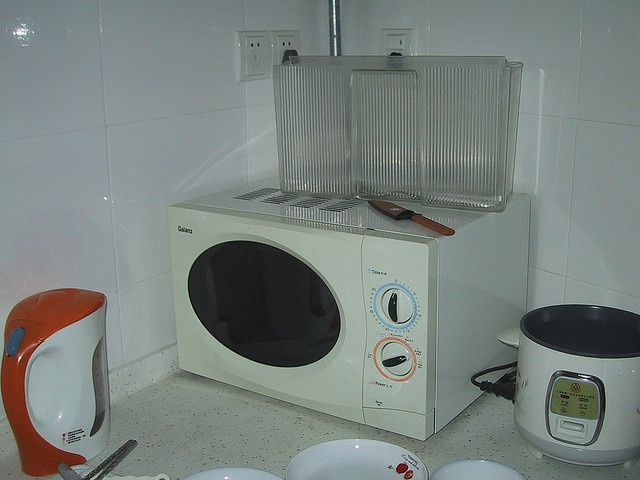Describe the objects in this image and their specific colors. I can see microwave in gray, darkgray, and black tones, bowl in gray, darkgray, and maroon tones, bowl in gray and darkgray tones, bowl in gray and darkgray tones, and knife in gray, maroon, and black tones in this image. 